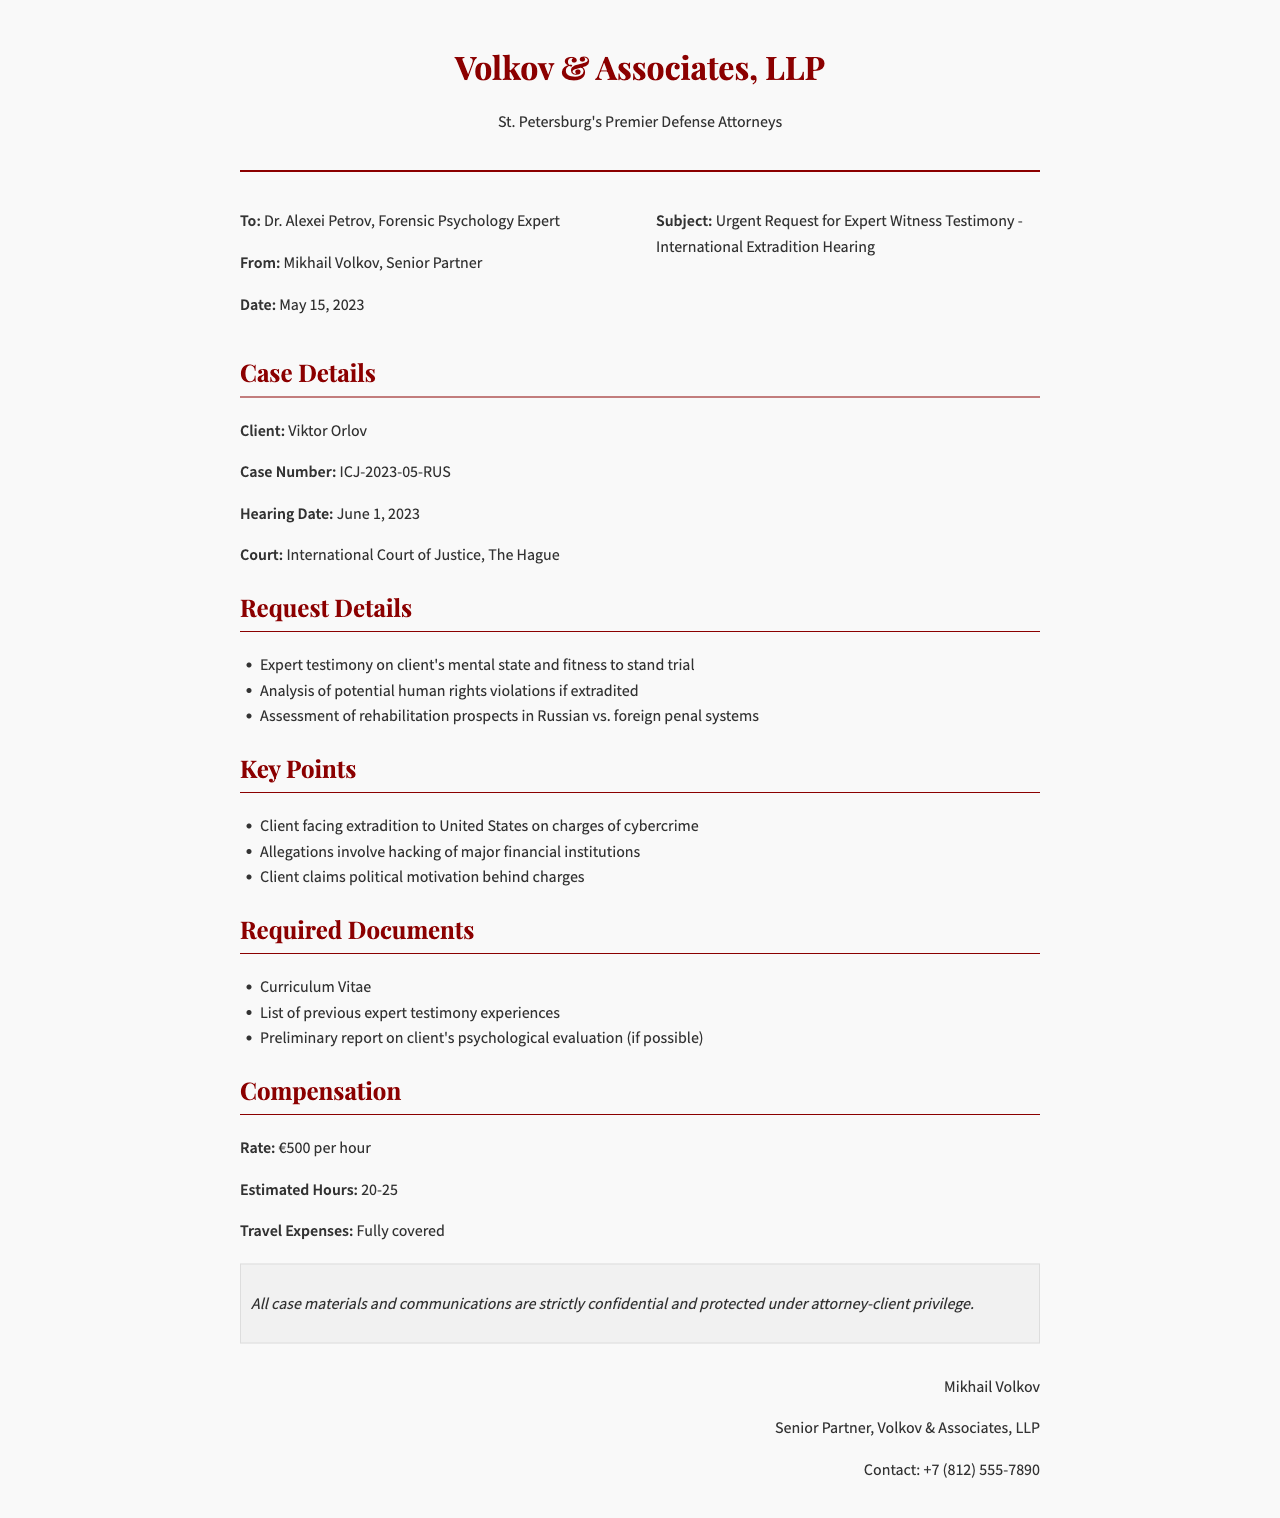What is the name of the expert witness requested? The fax requests Dr. Alexei Petrov for expert witness testimony.
Answer: Dr. Alexei Petrov Who is the client in this case? The client's name is mentioned clearly in the case details section as Viktor Orlov.
Answer: Viktor Orlov What is the hearing date? The hearing date is directly stated in the case details section as June 1, 2023.
Answer: June 1, 2023 What is the subject of the fax? The subject of the fax indicates the urgent request for expert witness testimony related to an international extradition hearing.
Answer: Urgent Request for Expert Witness Testimony - International Extradition Hearing What is the hourly rate for the expert witness? The compensation section specifies that the rate is €500 per hour.
Answer: €500 per hour What charges is the client facing? The key points section outlines that the client is facing extradition on charges of cybercrime.
Answer: cybercrime What court will the hearing take place in? The court is mentioned as the International Court of Justice, located in The Hague.
Answer: International Court of Justice, The Hague What are the estimated hours of work for the expert witness? The compensation section states that the estimated hours are between 20 to 25.
Answer: 20-25 What document is required to assess previous expert testimony experiences? The required documents section mentions a list of previous expert testimony experiences.
Answer: List of previous expert testimony experiences 